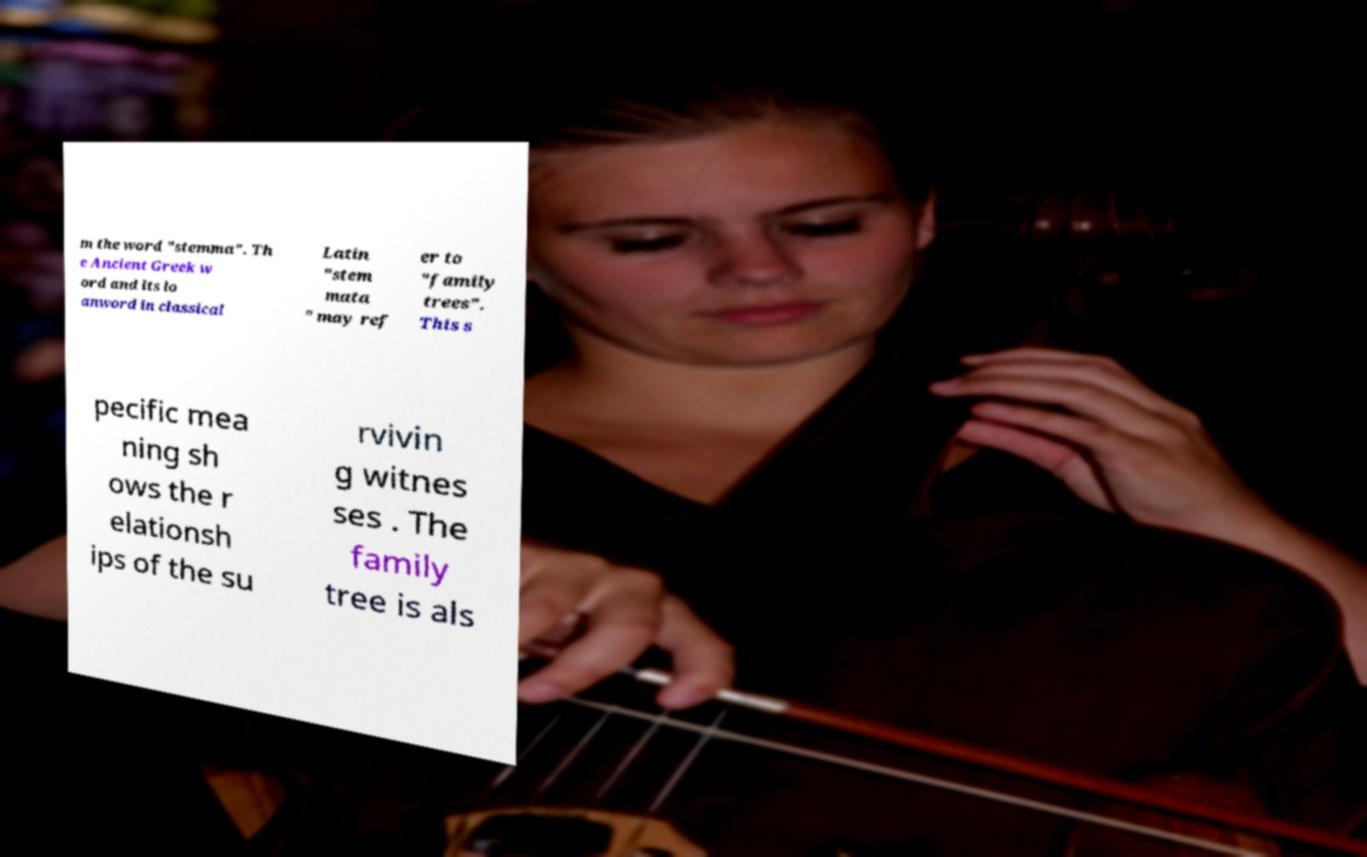There's text embedded in this image that I need extracted. Can you transcribe it verbatim? m the word "stemma". Th e Ancient Greek w ord and its lo anword in classical Latin "stem mata " may ref er to "family trees". This s pecific mea ning sh ows the r elationsh ips of the su rvivin g witnes ses . The family tree is als 